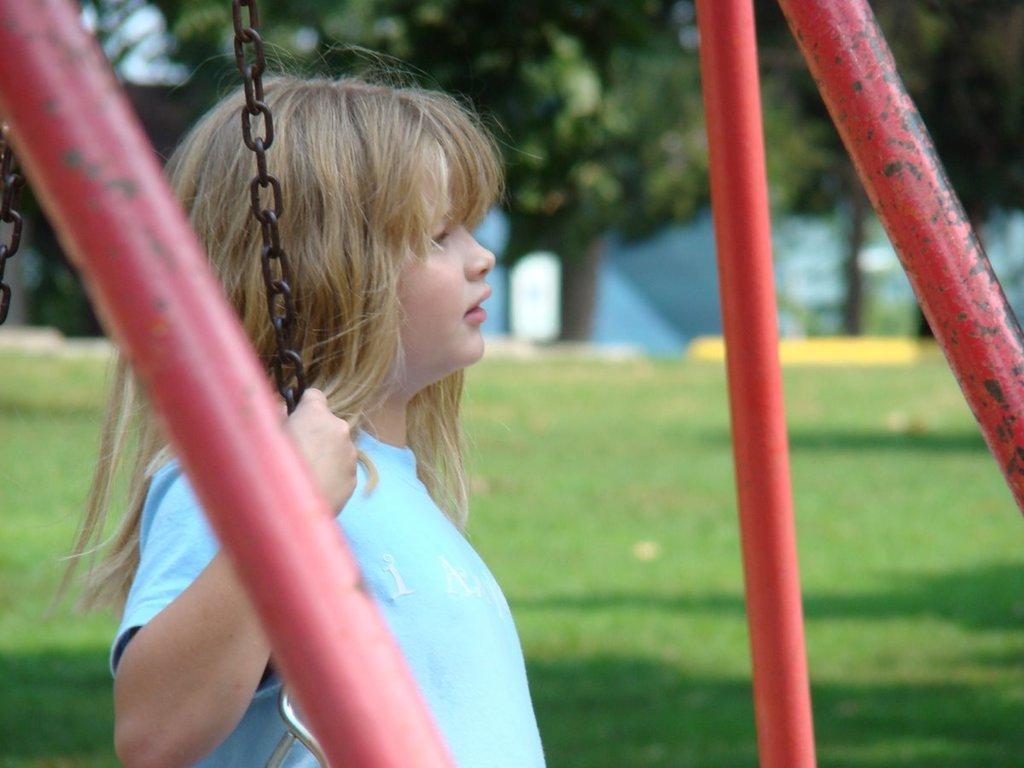Can you describe this image briefly? In the foreground round of the picture we can see iron poles and a girl holding chain. In the middle there is grass. In the background we can see trees and some blue color object. 